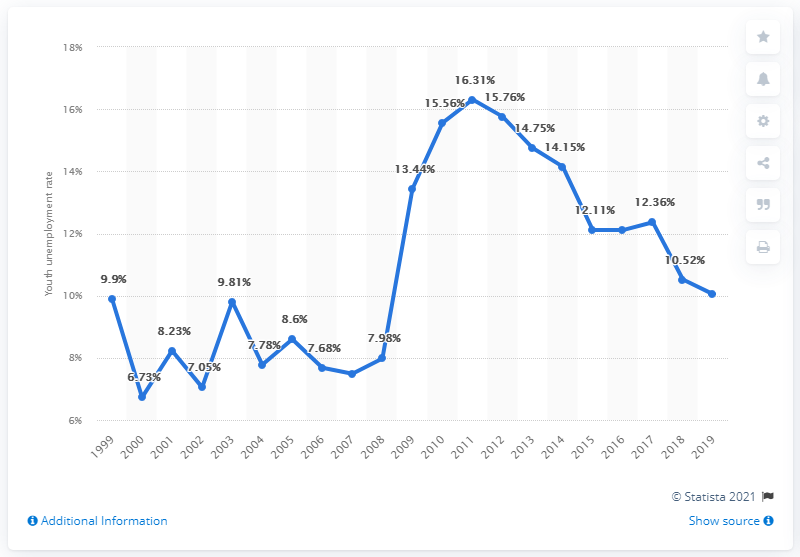Identify some key points in this picture. In 2019, the youth unemployment rate in Denmark was 10.05%. 